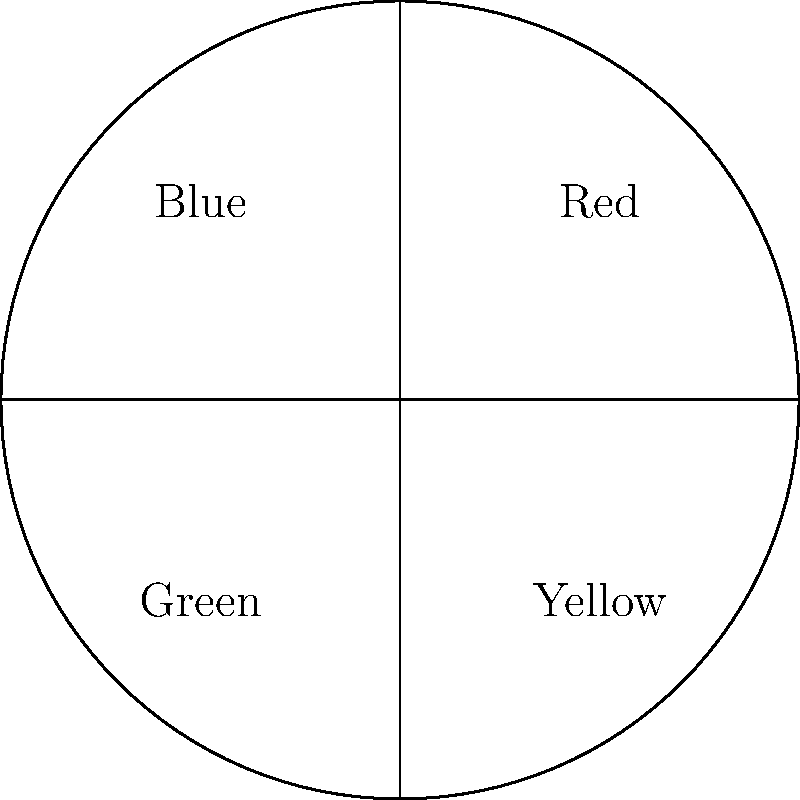Your grandchild has found your old spinning top with four colored sections: red, blue, green, and yellow, as shown in the diagram. If the top is spun 60 times, what is the probability of getting more red or blue outcomes than green or yellow outcomes? Let's approach this step-by-step:

1) First, we need to understand what the question is asking. We're looking for the probability of (Red + Blue) > (Green + Yellow) after 60 spins.

2) From the diagram, we can see that each color occupies 1/4 of the circle. This means each color has an equal probability of 1/4 on any single spin.

3) We can treat this as a binomial probability problem. Let's consider a "success" as getting either red or blue, and a "failure" as getting either green or yellow.

4) The probability of success (red or blue) on a single spin is 1/4 + 1/4 = 1/2.

5) We want the probability of getting more than 30 successes in 60 trials. This can be calculated as:

   $$P(X > 30) = 1 - P(X \leq 30)$$

   where X is the number of successes (red or blue outcomes).

6) Using the binomial distribution formula:

   $$P(X \leq 30) = \sum_{k=0}^{30} \binom{60}{k} (0.5)^k (0.5)^{60-k}$$

7) This sum is approximately 0.5.

8) Therefore, $P(X > 30) = 1 - 0.5 = 0.5$
Answer: 0.5 or 50% 